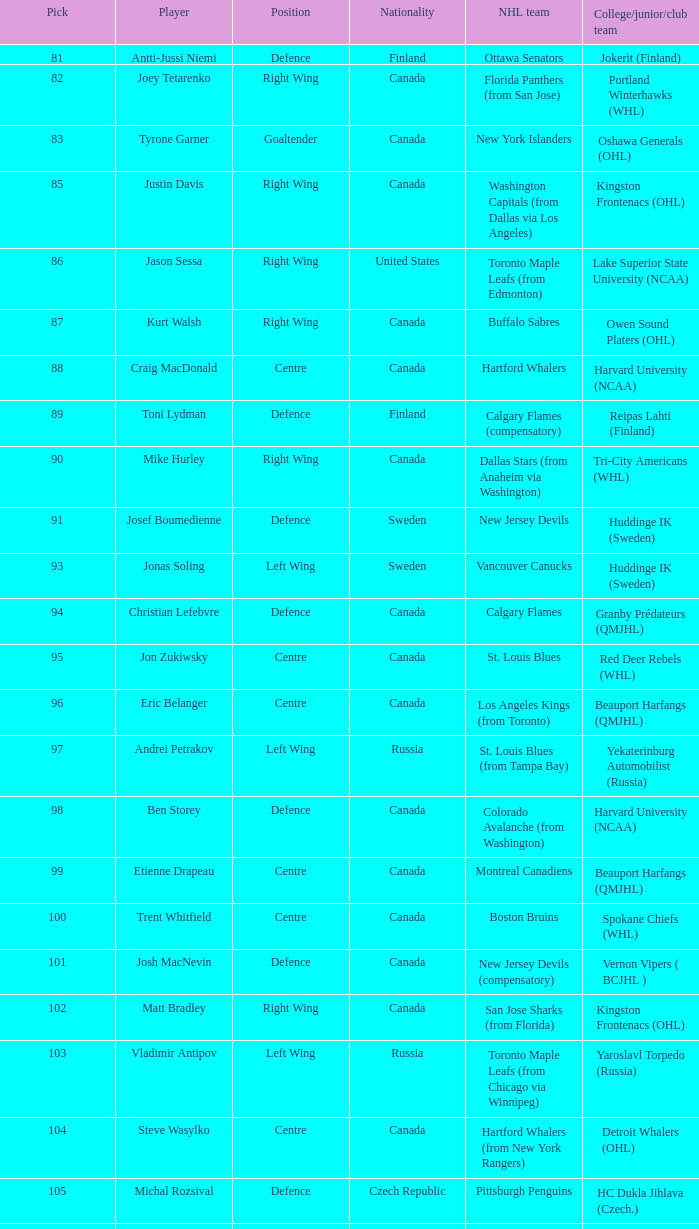What position does Antti-Jussi Niemi play? Defence. 